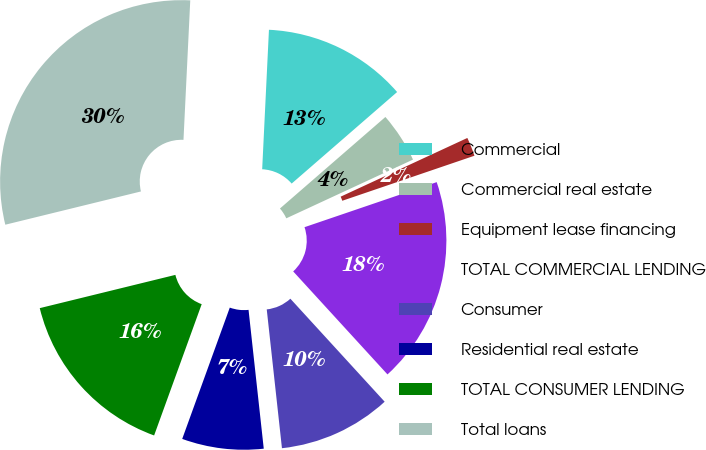Convert chart. <chart><loc_0><loc_0><loc_500><loc_500><pie_chart><fcel>Commercial<fcel>Commercial real estate<fcel>Equipment lease financing<fcel>TOTAL COMMERCIAL LENDING<fcel>Consumer<fcel>Residential real estate<fcel>TOTAL CONSUMER LENDING<fcel>Total loans<nl><fcel>12.85%<fcel>4.47%<fcel>1.68%<fcel>18.43%<fcel>10.06%<fcel>7.27%<fcel>15.64%<fcel>29.6%<nl></chart> 